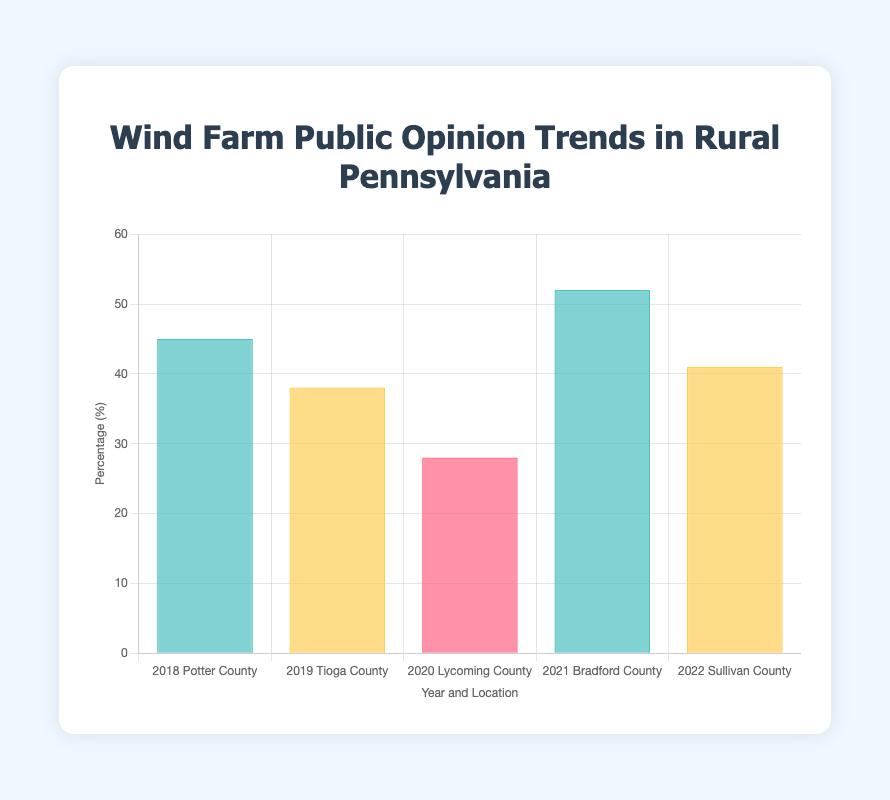Which year and location had the highest percentage of positive sentiment (😀) towards wind farm development? First, identify the bars with the highest value associated with the 😀 sentiment. Bradford County in 2021 had a 52% positive sentiment, which is the highest.
Answer: 2021, Bradford County What percentage of the public opinion was neutral (😐) in Tioga County in 2019? Look for the bar labeled 2019 with Tioga County and check the corresponding percentage. It shows 38%.
Answer: 38% How does the public opinion in Potter County in 2018 compare to Lycoming County in 2020? Compare the percentages for the respective years: Potter County in 2018 had 45% (😀) while Lycoming County in 2020 had 28% (😠). Potter County had a higher percentage.
Answer: Higher in Potter County Which location and year had the lowest percentage of public opinion, and what was the corresponding sentiment? Identify the bar with the lowest percentage: Lycoming County in 2020 had the lowest percentage at 28%, with a sentiment of 😠.
Answer: 2020, Lycoming County, 😠 Calculate the average percentage of public opinion for all locations and years. Sum all percentages and divide by the number of data points: (45 + 38 + 28 + 52 + 41) / 5 = 40.8%.
Answer: 40.8% How many times did the sentiment 😐 appear across all data points? Count the instances of the 😐 sentiment: Tioga County in 2019 and Sullivan County in 2022, totaling 2 times.
Answer: 2 times Which sentiment appeared most frequently in the data set? Count the occurrences of each sentiment: 😀 (2 times), 😐 (2 times), and 😠 (1 time). Both 😀 and 😐 appeared 2 times each, making them the most frequent.
Answer: 😀 and 😐 What is the difference in percentage between the highest negative sentiment (😠) and the lowest positive sentiment (😀)? Subtract the lowest positive percentage from the highest negative percentage: 45% (Potter County 2018, 😀) - 28% (Lycoming County 2020, 😠) = 17%.
Answer: 17% 